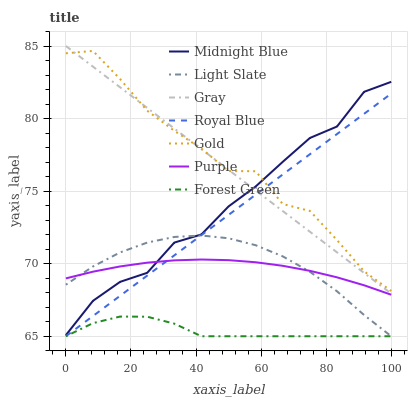Does Forest Green have the minimum area under the curve?
Answer yes or no. Yes. Does Gold have the maximum area under the curve?
Answer yes or no. Yes. Does Midnight Blue have the minimum area under the curve?
Answer yes or no. No. Does Midnight Blue have the maximum area under the curve?
Answer yes or no. No. Is Gray the smoothest?
Answer yes or no. Yes. Is Gold the roughest?
Answer yes or no. Yes. Is Midnight Blue the smoothest?
Answer yes or no. No. Is Midnight Blue the roughest?
Answer yes or no. No. Does Royal Blue have the lowest value?
Answer yes or no. Yes. Does Midnight Blue have the lowest value?
Answer yes or no. No. Does Gray have the highest value?
Answer yes or no. Yes. Does Midnight Blue have the highest value?
Answer yes or no. No. Is Forest Green less than Purple?
Answer yes or no. Yes. Is Gray greater than Forest Green?
Answer yes or no. Yes. Does Royal Blue intersect Gray?
Answer yes or no. Yes. Is Royal Blue less than Gray?
Answer yes or no. No. Is Royal Blue greater than Gray?
Answer yes or no. No. Does Forest Green intersect Purple?
Answer yes or no. No. 